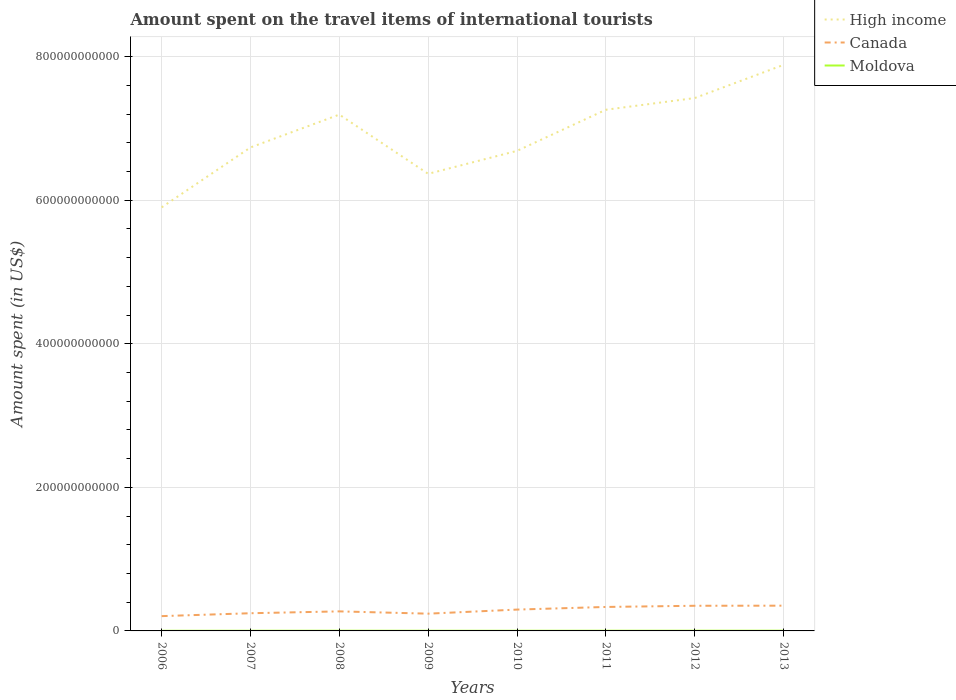Is the number of lines equal to the number of legend labels?
Keep it short and to the point. Yes. Across all years, what is the maximum amount spent on the travel items of international tourists in Canada?
Your response must be concise. 2.06e+1. In which year was the amount spent on the travel items of international tourists in High income maximum?
Offer a terse response. 2006. What is the total amount spent on the travel items of international tourists in Moldova in the graph?
Ensure brevity in your answer.  -2.00e+07. What is the difference between the highest and the second highest amount spent on the travel items of international tourists in Canada?
Provide a short and direct response. 1.46e+1. What is the difference between the highest and the lowest amount spent on the travel items of international tourists in Canada?
Offer a very short reply. 4. Is the amount spent on the travel items of international tourists in High income strictly greater than the amount spent on the travel items of international tourists in Canada over the years?
Give a very brief answer. No. How many lines are there?
Offer a very short reply. 3. What is the difference between two consecutive major ticks on the Y-axis?
Make the answer very short. 2.00e+11. Are the values on the major ticks of Y-axis written in scientific E-notation?
Keep it short and to the point. No. What is the title of the graph?
Your answer should be very brief. Amount spent on the travel items of international tourists. What is the label or title of the X-axis?
Keep it short and to the point. Years. What is the label or title of the Y-axis?
Your answer should be compact. Amount spent (in US$). What is the Amount spent (in US$) of High income in 2006?
Offer a very short reply. 5.90e+11. What is the Amount spent (in US$) in Canada in 2006?
Ensure brevity in your answer.  2.06e+1. What is the Amount spent (in US$) in Moldova in 2006?
Provide a short and direct response. 1.90e+08. What is the Amount spent (in US$) of High income in 2007?
Ensure brevity in your answer.  6.73e+11. What is the Amount spent (in US$) in Canada in 2007?
Provide a short and direct response. 2.46e+1. What is the Amount spent (in US$) in Moldova in 2007?
Your answer should be very brief. 2.33e+08. What is the Amount spent (in US$) in High income in 2008?
Provide a short and direct response. 7.19e+11. What is the Amount spent (in US$) in Canada in 2008?
Your response must be concise. 2.72e+1. What is the Amount spent (in US$) in Moldova in 2008?
Provide a short and direct response. 2.88e+08. What is the Amount spent (in US$) of High income in 2009?
Ensure brevity in your answer.  6.37e+11. What is the Amount spent (in US$) of Canada in 2009?
Ensure brevity in your answer.  2.40e+1. What is the Amount spent (in US$) in Moldova in 2009?
Offer a very short reply. 2.43e+08. What is the Amount spent (in US$) of High income in 2010?
Provide a short and direct response. 6.69e+11. What is the Amount spent (in US$) in Canada in 2010?
Provide a succinct answer. 2.97e+1. What is the Amount spent (in US$) in Moldova in 2010?
Offer a very short reply. 2.41e+08. What is the Amount spent (in US$) in High income in 2011?
Keep it short and to the point. 7.26e+11. What is the Amount spent (in US$) in Canada in 2011?
Provide a succinct answer. 3.34e+1. What is the Amount spent (in US$) of Moldova in 2011?
Your response must be concise. 2.77e+08. What is the Amount spent (in US$) in High income in 2012?
Your answer should be compact. 7.42e+11. What is the Amount spent (in US$) of Canada in 2012?
Keep it short and to the point. 3.50e+1. What is the Amount spent (in US$) in Moldova in 2012?
Your response must be concise. 3.08e+08. What is the Amount spent (in US$) in High income in 2013?
Offer a very short reply. 7.88e+11. What is the Amount spent (in US$) of Canada in 2013?
Your response must be concise. 3.52e+1. What is the Amount spent (in US$) in Moldova in 2013?
Your answer should be compact. 3.34e+08. Across all years, what is the maximum Amount spent (in US$) of High income?
Your answer should be compact. 7.88e+11. Across all years, what is the maximum Amount spent (in US$) in Canada?
Provide a succinct answer. 3.52e+1. Across all years, what is the maximum Amount spent (in US$) in Moldova?
Your answer should be compact. 3.34e+08. Across all years, what is the minimum Amount spent (in US$) of High income?
Give a very brief answer. 5.90e+11. Across all years, what is the minimum Amount spent (in US$) in Canada?
Your answer should be compact. 2.06e+1. Across all years, what is the minimum Amount spent (in US$) of Moldova?
Provide a short and direct response. 1.90e+08. What is the total Amount spent (in US$) of High income in the graph?
Give a very brief answer. 5.54e+12. What is the total Amount spent (in US$) in Canada in the graph?
Offer a terse response. 2.30e+11. What is the total Amount spent (in US$) of Moldova in the graph?
Make the answer very short. 2.11e+09. What is the difference between the Amount spent (in US$) in High income in 2006 and that in 2007?
Make the answer very short. -8.35e+1. What is the difference between the Amount spent (in US$) in Canada in 2006 and that in 2007?
Give a very brief answer. -4.03e+09. What is the difference between the Amount spent (in US$) of Moldova in 2006 and that in 2007?
Your response must be concise. -4.30e+07. What is the difference between the Amount spent (in US$) of High income in 2006 and that in 2008?
Provide a succinct answer. -1.29e+11. What is the difference between the Amount spent (in US$) in Canada in 2006 and that in 2008?
Your answer should be very brief. -6.61e+09. What is the difference between the Amount spent (in US$) of Moldova in 2006 and that in 2008?
Your response must be concise. -9.80e+07. What is the difference between the Amount spent (in US$) in High income in 2006 and that in 2009?
Give a very brief answer. -4.67e+1. What is the difference between the Amount spent (in US$) in Canada in 2006 and that in 2009?
Ensure brevity in your answer.  -3.42e+09. What is the difference between the Amount spent (in US$) in Moldova in 2006 and that in 2009?
Ensure brevity in your answer.  -5.30e+07. What is the difference between the Amount spent (in US$) of High income in 2006 and that in 2010?
Make the answer very short. -7.87e+1. What is the difference between the Amount spent (in US$) of Canada in 2006 and that in 2010?
Provide a short and direct response. -9.11e+09. What is the difference between the Amount spent (in US$) of Moldova in 2006 and that in 2010?
Offer a very short reply. -5.10e+07. What is the difference between the Amount spent (in US$) of High income in 2006 and that in 2011?
Your answer should be very brief. -1.36e+11. What is the difference between the Amount spent (in US$) in Canada in 2006 and that in 2011?
Your response must be concise. -1.28e+1. What is the difference between the Amount spent (in US$) in Moldova in 2006 and that in 2011?
Offer a terse response. -8.70e+07. What is the difference between the Amount spent (in US$) of High income in 2006 and that in 2012?
Offer a terse response. -1.52e+11. What is the difference between the Amount spent (in US$) in Canada in 2006 and that in 2012?
Keep it short and to the point. -1.44e+1. What is the difference between the Amount spent (in US$) of Moldova in 2006 and that in 2012?
Give a very brief answer. -1.18e+08. What is the difference between the Amount spent (in US$) in High income in 2006 and that in 2013?
Ensure brevity in your answer.  -1.98e+11. What is the difference between the Amount spent (in US$) of Canada in 2006 and that in 2013?
Provide a short and direct response. -1.46e+1. What is the difference between the Amount spent (in US$) of Moldova in 2006 and that in 2013?
Keep it short and to the point. -1.44e+08. What is the difference between the Amount spent (in US$) in High income in 2007 and that in 2008?
Provide a succinct answer. -4.58e+1. What is the difference between the Amount spent (in US$) in Canada in 2007 and that in 2008?
Offer a terse response. -2.58e+09. What is the difference between the Amount spent (in US$) of Moldova in 2007 and that in 2008?
Provide a succinct answer. -5.50e+07. What is the difference between the Amount spent (in US$) of High income in 2007 and that in 2009?
Your response must be concise. 3.67e+1. What is the difference between the Amount spent (in US$) in Canada in 2007 and that in 2009?
Provide a short and direct response. 6.03e+08. What is the difference between the Amount spent (in US$) of Moldova in 2007 and that in 2009?
Keep it short and to the point. -1.00e+07. What is the difference between the Amount spent (in US$) of High income in 2007 and that in 2010?
Your answer should be very brief. 4.75e+09. What is the difference between the Amount spent (in US$) of Canada in 2007 and that in 2010?
Your answer should be very brief. -5.09e+09. What is the difference between the Amount spent (in US$) of Moldova in 2007 and that in 2010?
Offer a terse response. -8.00e+06. What is the difference between the Amount spent (in US$) in High income in 2007 and that in 2011?
Provide a succinct answer. -5.25e+1. What is the difference between the Amount spent (in US$) in Canada in 2007 and that in 2011?
Provide a succinct answer. -8.75e+09. What is the difference between the Amount spent (in US$) in Moldova in 2007 and that in 2011?
Provide a succinct answer. -4.40e+07. What is the difference between the Amount spent (in US$) of High income in 2007 and that in 2012?
Make the answer very short. -6.88e+1. What is the difference between the Amount spent (in US$) in Canada in 2007 and that in 2012?
Offer a very short reply. -1.04e+1. What is the difference between the Amount spent (in US$) in Moldova in 2007 and that in 2012?
Your answer should be very brief. -7.50e+07. What is the difference between the Amount spent (in US$) of High income in 2007 and that in 2013?
Offer a very short reply. -1.15e+11. What is the difference between the Amount spent (in US$) in Canada in 2007 and that in 2013?
Provide a short and direct response. -1.05e+1. What is the difference between the Amount spent (in US$) in Moldova in 2007 and that in 2013?
Your answer should be compact. -1.01e+08. What is the difference between the Amount spent (in US$) in High income in 2008 and that in 2009?
Provide a succinct answer. 8.25e+1. What is the difference between the Amount spent (in US$) in Canada in 2008 and that in 2009?
Provide a succinct answer. 3.19e+09. What is the difference between the Amount spent (in US$) in Moldova in 2008 and that in 2009?
Provide a succinct answer. 4.50e+07. What is the difference between the Amount spent (in US$) of High income in 2008 and that in 2010?
Offer a very short reply. 5.05e+1. What is the difference between the Amount spent (in US$) of Canada in 2008 and that in 2010?
Make the answer very short. -2.50e+09. What is the difference between the Amount spent (in US$) of Moldova in 2008 and that in 2010?
Give a very brief answer. 4.70e+07. What is the difference between the Amount spent (in US$) in High income in 2008 and that in 2011?
Offer a terse response. -6.76e+09. What is the difference between the Amount spent (in US$) of Canada in 2008 and that in 2011?
Your answer should be compact. -6.16e+09. What is the difference between the Amount spent (in US$) in Moldova in 2008 and that in 2011?
Provide a short and direct response. 1.10e+07. What is the difference between the Amount spent (in US$) in High income in 2008 and that in 2012?
Ensure brevity in your answer.  -2.31e+1. What is the difference between the Amount spent (in US$) of Canada in 2008 and that in 2012?
Your answer should be very brief. -7.81e+09. What is the difference between the Amount spent (in US$) in Moldova in 2008 and that in 2012?
Your answer should be compact. -2.00e+07. What is the difference between the Amount spent (in US$) in High income in 2008 and that in 2013?
Your response must be concise. -6.93e+1. What is the difference between the Amount spent (in US$) of Canada in 2008 and that in 2013?
Ensure brevity in your answer.  -7.94e+09. What is the difference between the Amount spent (in US$) in Moldova in 2008 and that in 2013?
Provide a short and direct response. -4.60e+07. What is the difference between the Amount spent (in US$) in High income in 2009 and that in 2010?
Your answer should be very brief. -3.20e+1. What is the difference between the Amount spent (in US$) of Canada in 2009 and that in 2010?
Keep it short and to the point. -5.69e+09. What is the difference between the Amount spent (in US$) in High income in 2009 and that in 2011?
Offer a terse response. -8.93e+1. What is the difference between the Amount spent (in US$) in Canada in 2009 and that in 2011?
Your answer should be compact. -9.35e+09. What is the difference between the Amount spent (in US$) in Moldova in 2009 and that in 2011?
Provide a succinct answer. -3.40e+07. What is the difference between the Amount spent (in US$) in High income in 2009 and that in 2012?
Keep it short and to the point. -1.06e+11. What is the difference between the Amount spent (in US$) in Canada in 2009 and that in 2012?
Provide a succinct answer. -1.10e+1. What is the difference between the Amount spent (in US$) in Moldova in 2009 and that in 2012?
Keep it short and to the point. -6.50e+07. What is the difference between the Amount spent (in US$) in High income in 2009 and that in 2013?
Your answer should be compact. -1.52e+11. What is the difference between the Amount spent (in US$) of Canada in 2009 and that in 2013?
Provide a succinct answer. -1.11e+1. What is the difference between the Amount spent (in US$) of Moldova in 2009 and that in 2013?
Provide a succinct answer. -9.10e+07. What is the difference between the Amount spent (in US$) in High income in 2010 and that in 2011?
Provide a succinct answer. -5.73e+1. What is the difference between the Amount spent (in US$) in Canada in 2010 and that in 2011?
Offer a very short reply. -3.66e+09. What is the difference between the Amount spent (in US$) in Moldova in 2010 and that in 2011?
Offer a terse response. -3.60e+07. What is the difference between the Amount spent (in US$) in High income in 2010 and that in 2012?
Your answer should be compact. -7.36e+1. What is the difference between the Amount spent (in US$) in Canada in 2010 and that in 2012?
Your answer should be very brief. -5.31e+09. What is the difference between the Amount spent (in US$) of Moldova in 2010 and that in 2012?
Make the answer very short. -6.70e+07. What is the difference between the Amount spent (in US$) in High income in 2010 and that in 2013?
Offer a very short reply. -1.20e+11. What is the difference between the Amount spent (in US$) in Canada in 2010 and that in 2013?
Offer a very short reply. -5.44e+09. What is the difference between the Amount spent (in US$) in Moldova in 2010 and that in 2013?
Provide a short and direct response. -9.30e+07. What is the difference between the Amount spent (in US$) in High income in 2011 and that in 2012?
Make the answer very short. -1.63e+1. What is the difference between the Amount spent (in US$) in Canada in 2011 and that in 2012?
Ensure brevity in your answer.  -1.65e+09. What is the difference between the Amount spent (in US$) in Moldova in 2011 and that in 2012?
Make the answer very short. -3.10e+07. What is the difference between the Amount spent (in US$) in High income in 2011 and that in 2013?
Offer a terse response. -6.25e+1. What is the difference between the Amount spent (in US$) in Canada in 2011 and that in 2013?
Your response must be concise. -1.78e+09. What is the difference between the Amount spent (in US$) in Moldova in 2011 and that in 2013?
Make the answer very short. -5.70e+07. What is the difference between the Amount spent (in US$) in High income in 2012 and that in 2013?
Make the answer very short. -4.62e+1. What is the difference between the Amount spent (in US$) in Canada in 2012 and that in 2013?
Offer a terse response. -1.32e+08. What is the difference between the Amount spent (in US$) of Moldova in 2012 and that in 2013?
Provide a short and direct response. -2.60e+07. What is the difference between the Amount spent (in US$) in High income in 2006 and the Amount spent (in US$) in Canada in 2007?
Ensure brevity in your answer.  5.65e+11. What is the difference between the Amount spent (in US$) of High income in 2006 and the Amount spent (in US$) of Moldova in 2007?
Offer a very short reply. 5.90e+11. What is the difference between the Amount spent (in US$) in Canada in 2006 and the Amount spent (in US$) in Moldova in 2007?
Your answer should be very brief. 2.04e+1. What is the difference between the Amount spent (in US$) of High income in 2006 and the Amount spent (in US$) of Canada in 2008?
Offer a terse response. 5.63e+11. What is the difference between the Amount spent (in US$) in High income in 2006 and the Amount spent (in US$) in Moldova in 2008?
Provide a succinct answer. 5.90e+11. What is the difference between the Amount spent (in US$) in Canada in 2006 and the Amount spent (in US$) in Moldova in 2008?
Offer a very short reply. 2.03e+1. What is the difference between the Amount spent (in US$) of High income in 2006 and the Amount spent (in US$) of Canada in 2009?
Your answer should be compact. 5.66e+11. What is the difference between the Amount spent (in US$) of High income in 2006 and the Amount spent (in US$) of Moldova in 2009?
Offer a terse response. 5.90e+11. What is the difference between the Amount spent (in US$) in Canada in 2006 and the Amount spent (in US$) in Moldova in 2009?
Provide a succinct answer. 2.04e+1. What is the difference between the Amount spent (in US$) in High income in 2006 and the Amount spent (in US$) in Canada in 2010?
Provide a short and direct response. 5.60e+11. What is the difference between the Amount spent (in US$) of High income in 2006 and the Amount spent (in US$) of Moldova in 2010?
Give a very brief answer. 5.90e+11. What is the difference between the Amount spent (in US$) of Canada in 2006 and the Amount spent (in US$) of Moldova in 2010?
Provide a short and direct response. 2.04e+1. What is the difference between the Amount spent (in US$) of High income in 2006 and the Amount spent (in US$) of Canada in 2011?
Provide a succinct answer. 5.57e+11. What is the difference between the Amount spent (in US$) of High income in 2006 and the Amount spent (in US$) of Moldova in 2011?
Offer a very short reply. 5.90e+11. What is the difference between the Amount spent (in US$) in Canada in 2006 and the Amount spent (in US$) in Moldova in 2011?
Provide a short and direct response. 2.03e+1. What is the difference between the Amount spent (in US$) of High income in 2006 and the Amount spent (in US$) of Canada in 2012?
Keep it short and to the point. 5.55e+11. What is the difference between the Amount spent (in US$) of High income in 2006 and the Amount spent (in US$) of Moldova in 2012?
Your answer should be very brief. 5.90e+11. What is the difference between the Amount spent (in US$) of Canada in 2006 and the Amount spent (in US$) of Moldova in 2012?
Your response must be concise. 2.03e+1. What is the difference between the Amount spent (in US$) of High income in 2006 and the Amount spent (in US$) of Canada in 2013?
Provide a short and direct response. 5.55e+11. What is the difference between the Amount spent (in US$) of High income in 2006 and the Amount spent (in US$) of Moldova in 2013?
Your response must be concise. 5.90e+11. What is the difference between the Amount spent (in US$) of Canada in 2006 and the Amount spent (in US$) of Moldova in 2013?
Keep it short and to the point. 2.03e+1. What is the difference between the Amount spent (in US$) of High income in 2007 and the Amount spent (in US$) of Canada in 2008?
Your response must be concise. 6.46e+11. What is the difference between the Amount spent (in US$) of High income in 2007 and the Amount spent (in US$) of Moldova in 2008?
Make the answer very short. 6.73e+11. What is the difference between the Amount spent (in US$) of Canada in 2007 and the Amount spent (in US$) of Moldova in 2008?
Make the answer very short. 2.44e+1. What is the difference between the Amount spent (in US$) in High income in 2007 and the Amount spent (in US$) in Canada in 2009?
Keep it short and to the point. 6.49e+11. What is the difference between the Amount spent (in US$) of High income in 2007 and the Amount spent (in US$) of Moldova in 2009?
Your response must be concise. 6.73e+11. What is the difference between the Amount spent (in US$) in Canada in 2007 and the Amount spent (in US$) in Moldova in 2009?
Offer a terse response. 2.44e+1. What is the difference between the Amount spent (in US$) of High income in 2007 and the Amount spent (in US$) of Canada in 2010?
Provide a succinct answer. 6.44e+11. What is the difference between the Amount spent (in US$) in High income in 2007 and the Amount spent (in US$) in Moldova in 2010?
Ensure brevity in your answer.  6.73e+11. What is the difference between the Amount spent (in US$) of Canada in 2007 and the Amount spent (in US$) of Moldova in 2010?
Provide a short and direct response. 2.44e+1. What is the difference between the Amount spent (in US$) of High income in 2007 and the Amount spent (in US$) of Canada in 2011?
Provide a succinct answer. 6.40e+11. What is the difference between the Amount spent (in US$) of High income in 2007 and the Amount spent (in US$) of Moldova in 2011?
Give a very brief answer. 6.73e+11. What is the difference between the Amount spent (in US$) in Canada in 2007 and the Amount spent (in US$) in Moldova in 2011?
Your answer should be very brief. 2.44e+1. What is the difference between the Amount spent (in US$) in High income in 2007 and the Amount spent (in US$) in Canada in 2012?
Provide a succinct answer. 6.38e+11. What is the difference between the Amount spent (in US$) of High income in 2007 and the Amount spent (in US$) of Moldova in 2012?
Keep it short and to the point. 6.73e+11. What is the difference between the Amount spent (in US$) in Canada in 2007 and the Amount spent (in US$) in Moldova in 2012?
Provide a succinct answer. 2.43e+1. What is the difference between the Amount spent (in US$) in High income in 2007 and the Amount spent (in US$) in Canada in 2013?
Provide a succinct answer. 6.38e+11. What is the difference between the Amount spent (in US$) in High income in 2007 and the Amount spent (in US$) in Moldova in 2013?
Keep it short and to the point. 6.73e+11. What is the difference between the Amount spent (in US$) in Canada in 2007 and the Amount spent (in US$) in Moldova in 2013?
Offer a very short reply. 2.43e+1. What is the difference between the Amount spent (in US$) in High income in 2008 and the Amount spent (in US$) in Canada in 2009?
Ensure brevity in your answer.  6.95e+11. What is the difference between the Amount spent (in US$) in High income in 2008 and the Amount spent (in US$) in Moldova in 2009?
Ensure brevity in your answer.  7.19e+11. What is the difference between the Amount spent (in US$) of Canada in 2008 and the Amount spent (in US$) of Moldova in 2009?
Make the answer very short. 2.70e+1. What is the difference between the Amount spent (in US$) of High income in 2008 and the Amount spent (in US$) of Canada in 2010?
Provide a succinct answer. 6.89e+11. What is the difference between the Amount spent (in US$) in High income in 2008 and the Amount spent (in US$) in Moldova in 2010?
Offer a very short reply. 7.19e+11. What is the difference between the Amount spent (in US$) in Canada in 2008 and the Amount spent (in US$) in Moldova in 2010?
Provide a short and direct response. 2.70e+1. What is the difference between the Amount spent (in US$) of High income in 2008 and the Amount spent (in US$) of Canada in 2011?
Offer a terse response. 6.86e+11. What is the difference between the Amount spent (in US$) in High income in 2008 and the Amount spent (in US$) in Moldova in 2011?
Make the answer very short. 7.19e+11. What is the difference between the Amount spent (in US$) of Canada in 2008 and the Amount spent (in US$) of Moldova in 2011?
Provide a succinct answer. 2.69e+1. What is the difference between the Amount spent (in US$) in High income in 2008 and the Amount spent (in US$) in Canada in 2012?
Provide a succinct answer. 6.84e+11. What is the difference between the Amount spent (in US$) of High income in 2008 and the Amount spent (in US$) of Moldova in 2012?
Make the answer very short. 7.19e+11. What is the difference between the Amount spent (in US$) in Canada in 2008 and the Amount spent (in US$) in Moldova in 2012?
Give a very brief answer. 2.69e+1. What is the difference between the Amount spent (in US$) of High income in 2008 and the Amount spent (in US$) of Canada in 2013?
Offer a terse response. 6.84e+11. What is the difference between the Amount spent (in US$) in High income in 2008 and the Amount spent (in US$) in Moldova in 2013?
Give a very brief answer. 7.19e+11. What is the difference between the Amount spent (in US$) of Canada in 2008 and the Amount spent (in US$) of Moldova in 2013?
Offer a terse response. 2.69e+1. What is the difference between the Amount spent (in US$) in High income in 2009 and the Amount spent (in US$) in Canada in 2010?
Offer a very short reply. 6.07e+11. What is the difference between the Amount spent (in US$) in High income in 2009 and the Amount spent (in US$) in Moldova in 2010?
Offer a terse response. 6.36e+11. What is the difference between the Amount spent (in US$) of Canada in 2009 and the Amount spent (in US$) of Moldova in 2010?
Your answer should be compact. 2.38e+1. What is the difference between the Amount spent (in US$) of High income in 2009 and the Amount spent (in US$) of Canada in 2011?
Your answer should be very brief. 6.03e+11. What is the difference between the Amount spent (in US$) in High income in 2009 and the Amount spent (in US$) in Moldova in 2011?
Provide a succinct answer. 6.36e+11. What is the difference between the Amount spent (in US$) in Canada in 2009 and the Amount spent (in US$) in Moldova in 2011?
Give a very brief answer. 2.38e+1. What is the difference between the Amount spent (in US$) of High income in 2009 and the Amount spent (in US$) of Canada in 2012?
Ensure brevity in your answer.  6.02e+11. What is the difference between the Amount spent (in US$) of High income in 2009 and the Amount spent (in US$) of Moldova in 2012?
Make the answer very short. 6.36e+11. What is the difference between the Amount spent (in US$) in Canada in 2009 and the Amount spent (in US$) in Moldova in 2012?
Keep it short and to the point. 2.37e+1. What is the difference between the Amount spent (in US$) in High income in 2009 and the Amount spent (in US$) in Canada in 2013?
Provide a succinct answer. 6.02e+11. What is the difference between the Amount spent (in US$) of High income in 2009 and the Amount spent (in US$) of Moldova in 2013?
Offer a very short reply. 6.36e+11. What is the difference between the Amount spent (in US$) of Canada in 2009 and the Amount spent (in US$) of Moldova in 2013?
Your response must be concise. 2.37e+1. What is the difference between the Amount spent (in US$) of High income in 2010 and the Amount spent (in US$) of Canada in 2011?
Provide a succinct answer. 6.35e+11. What is the difference between the Amount spent (in US$) of High income in 2010 and the Amount spent (in US$) of Moldova in 2011?
Give a very brief answer. 6.68e+11. What is the difference between the Amount spent (in US$) in Canada in 2010 and the Amount spent (in US$) in Moldova in 2011?
Provide a succinct answer. 2.94e+1. What is the difference between the Amount spent (in US$) in High income in 2010 and the Amount spent (in US$) in Canada in 2012?
Offer a very short reply. 6.34e+11. What is the difference between the Amount spent (in US$) in High income in 2010 and the Amount spent (in US$) in Moldova in 2012?
Your answer should be very brief. 6.68e+11. What is the difference between the Amount spent (in US$) in Canada in 2010 and the Amount spent (in US$) in Moldova in 2012?
Ensure brevity in your answer.  2.94e+1. What is the difference between the Amount spent (in US$) in High income in 2010 and the Amount spent (in US$) in Canada in 2013?
Your answer should be very brief. 6.34e+11. What is the difference between the Amount spent (in US$) of High income in 2010 and the Amount spent (in US$) of Moldova in 2013?
Make the answer very short. 6.68e+11. What is the difference between the Amount spent (in US$) of Canada in 2010 and the Amount spent (in US$) of Moldova in 2013?
Make the answer very short. 2.94e+1. What is the difference between the Amount spent (in US$) of High income in 2011 and the Amount spent (in US$) of Canada in 2012?
Ensure brevity in your answer.  6.91e+11. What is the difference between the Amount spent (in US$) in High income in 2011 and the Amount spent (in US$) in Moldova in 2012?
Make the answer very short. 7.26e+11. What is the difference between the Amount spent (in US$) in Canada in 2011 and the Amount spent (in US$) in Moldova in 2012?
Your answer should be very brief. 3.31e+1. What is the difference between the Amount spent (in US$) in High income in 2011 and the Amount spent (in US$) in Canada in 2013?
Give a very brief answer. 6.91e+11. What is the difference between the Amount spent (in US$) of High income in 2011 and the Amount spent (in US$) of Moldova in 2013?
Offer a very short reply. 7.26e+11. What is the difference between the Amount spent (in US$) in Canada in 2011 and the Amount spent (in US$) in Moldova in 2013?
Keep it short and to the point. 3.31e+1. What is the difference between the Amount spent (in US$) of High income in 2012 and the Amount spent (in US$) of Canada in 2013?
Ensure brevity in your answer.  7.07e+11. What is the difference between the Amount spent (in US$) of High income in 2012 and the Amount spent (in US$) of Moldova in 2013?
Offer a terse response. 7.42e+11. What is the difference between the Amount spent (in US$) of Canada in 2012 and the Amount spent (in US$) of Moldova in 2013?
Your answer should be very brief. 3.47e+1. What is the average Amount spent (in US$) of High income per year?
Provide a short and direct response. 6.93e+11. What is the average Amount spent (in US$) of Canada per year?
Your answer should be very brief. 2.87e+1. What is the average Amount spent (in US$) in Moldova per year?
Provide a short and direct response. 2.64e+08. In the year 2006, what is the difference between the Amount spent (in US$) in High income and Amount spent (in US$) in Canada?
Provide a succinct answer. 5.69e+11. In the year 2006, what is the difference between the Amount spent (in US$) in High income and Amount spent (in US$) in Moldova?
Keep it short and to the point. 5.90e+11. In the year 2006, what is the difference between the Amount spent (in US$) in Canada and Amount spent (in US$) in Moldova?
Your answer should be compact. 2.04e+1. In the year 2007, what is the difference between the Amount spent (in US$) in High income and Amount spent (in US$) in Canada?
Ensure brevity in your answer.  6.49e+11. In the year 2007, what is the difference between the Amount spent (in US$) of High income and Amount spent (in US$) of Moldova?
Keep it short and to the point. 6.73e+11. In the year 2007, what is the difference between the Amount spent (in US$) in Canada and Amount spent (in US$) in Moldova?
Your response must be concise. 2.44e+1. In the year 2008, what is the difference between the Amount spent (in US$) in High income and Amount spent (in US$) in Canada?
Provide a short and direct response. 6.92e+11. In the year 2008, what is the difference between the Amount spent (in US$) in High income and Amount spent (in US$) in Moldova?
Your answer should be very brief. 7.19e+11. In the year 2008, what is the difference between the Amount spent (in US$) in Canada and Amount spent (in US$) in Moldova?
Keep it short and to the point. 2.69e+1. In the year 2009, what is the difference between the Amount spent (in US$) of High income and Amount spent (in US$) of Canada?
Your answer should be very brief. 6.13e+11. In the year 2009, what is the difference between the Amount spent (in US$) in High income and Amount spent (in US$) in Moldova?
Ensure brevity in your answer.  6.36e+11. In the year 2009, what is the difference between the Amount spent (in US$) of Canada and Amount spent (in US$) of Moldova?
Keep it short and to the point. 2.38e+1. In the year 2010, what is the difference between the Amount spent (in US$) in High income and Amount spent (in US$) in Canada?
Provide a short and direct response. 6.39e+11. In the year 2010, what is the difference between the Amount spent (in US$) of High income and Amount spent (in US$) of Moldova?
Provide a short and direct response. 6.68e+11. In the year 2010, what is the difference between the Amount spent (in US$) in Canada and Amount spent (in US$) in Moldova?
Offer a very short reply. 2.95e+1. In the year 2011, what is the difference between the Amount spent (in US$) in High income and Amount spent (in US$) in Canada?
Make the answer very short. 6.93e+11. In the year 2011, what is the difference between the Amount spent (in US$) of High income and Amount spent (in US$) of Moldova?
Ensure brevity in your answer.  7.26e+11. In the year 2011, what is the difference between the Amount spent (in US$) in Canada and Amount spent (in US$) in Moldova?
Offer a very short reply. 3.31e+1. In the year 2012, what is the difference between the Amount spent (in US$) of High income and Amount spent (in US$) of Canada?
Keep it short and to the point. 7.07e+11. In the year 2012, what is the difference between the Amount spent (in US$) of High income and Amount spent (in US$) of Moldova?
Give a very brief answer. 7.42e+11. In the year 2012, what is the difference between the Amount spent (in US$) of Canada and Amount spent (in US$) of Moldova?
Provide a short and direct response. 3.47e+1. In the year 2013, what is the difference between the Amount spent (in US$) in High income and Amount spent (in US$) in Canada?
Make the answer very short. 7.53e+11. In the year 2013, what is the difference between the Amount spent (in US$) in High income and Amount spent (in US$) in Moldova?
Your response must be concise. 7.88e+11. In the year 2013, what is the difference between the Amount spent (in US$) in Canada and Amount spent (in US$) in Moldova?
Keep it short and to the point. 3.48e+1. What is the ratio of the Amount spent (in US$) of High income in 2006 to that in 2007?
Offer a very short reply. 0.88. What is the ratio of the Amount spent (in US$) of Canada in 2006 to that in 2007?
Your answer should be very brief. 0.84. What is the ratio of the Amount spent (in US$) in Moldova in 2006 to that in 2007?
Your answer should be compact. 0.82. What is the ratio of the Amount spent (in US$) in High income in 2006 to that in 2008?
Offer a terse response. 0.82. What is the ratio of the Amount spent (in US$) in Canada in 2006 to that in 2008?
Provide a succinct answer. 0.76. What is the ratio of the Amount spent (in US$) in Moldova in 2006 to that in 2008?
Your answer should be compact. 0.66. What is the ratio of the Amount spent (in US$) in High income in 2006 to that in 2009?
Your response must be concise. 0.93. What is the ratio of the Amount spent (in US$) of Canada in 2006 to that in 2009?
Ensure brevity in your answer.  0.86. What is the ratio of the Amount spent (in US$) of Moldova in 2006 to that in 2009?
Make the answer very short. 0.78. What is the ratio of the Amount spent (in US$) in High income in 2006 to that in 2010?
Offer a very short reply. 0.88. What is the ratio of the Amount spent (in US$) in Canada in 2006 to that in 2010?
Your response must be concise. 0.69. What is the ratio of the Amount spent (in US$) of Moldova in 2006 to that in 2010?
Provide a succinct answer. 0.79. What is the ratio of the Amount spent (in US$) of High income in 2006 to that in 2011?
Keep it short and to the point. 0.81. What is the ratio of the Amount spent (in US$) in Canada in 2006 to that in 2011?
Your answer should be compact. 0.62. What is the ratio of the Amount spent (in US$) of Moldova in 2006 to that in 2011?
Ensure brevity in your answer.  0.69. What is the ratio of the Amount spent (in US$) of High income in 2006 to that in 2012?
Your answer should be compact. 0.79. What is the ratio of the Amount spent (in US$) of Canada in 2006 to that in 2012?
Give a very brief answer. 0.59. What is the ratio of the Amount spent (in US$) in Moldova in 2006 to that in 2012?
Offer a terse response. 0.62. What is the ratio of the Amount spent (in US$) of High income in 2006 to that in 2013?
Your answer should be very brief. 0.75. What is the ratio of the Amount spent (in US$) in Canada in 2006 to that in 2013?
Give a very brief answer. 0.59. What is the ratio of the Amount spent (in US$) of Moldova in 2006 to that in 2013?
Your answer should be very brief. 0.57. What is the ratio of the Amount spent (in US$) of High income in 2007 to that in 2008?
Give a very brief answer. 0.94. What is the ratio of the Amount spent (in US$) in Canada in 2007 to that in 2008?
Your answer should be very brief. 0.91. What is the ratio of the Amount spent (in US$) of Moldova in 2007 to that in 2008?
Offer a very short reply. 0.81. What is the ratio of the Amount spent (in US$) in High income in 2007 to that in 2009?
Your response must be concise. 1.06. What is the ratio of the Amount spent (in US$) in Canada in 2007 to that in 2009?
Give a very brief answer. 1.03. What is the ratio of the Amount spent (in US$) in Moldova in 2007 to that in 2009?
Your answer should be very brief. 0.96. What is the ratio of the Amount spent (in US$) of High income in 2007 to that in 2010?
Your answer should be compact. 1.01. What is the ratio of the Amount spent (in US$) of Canada in 2007 to that in 2010?
Your response must be concise. 0.83. What is the ratio of the Amount spent (in US$) of Moldova in 2007 to that in 2010?
Keep it short and to the point. 0.97. What is the ratio of the Amount spent (in US$) of High income in 2007 to that in 2011?
Offer a very short reply. 0.93. What is the ratio of the Amount spent (in US$) in Canada in 2007 to that in 2011?
Provide a succinct answer. 0.74. What is the ratio of the Amount spent (in US$) of Moldova in 2007 to that in 2011?
Offer a very short reply. 0.84. What is the ratio of the Amount spent (in US$) in High income in 2007 to that in 2012?
Make the answer very short. 0.91. What is the ratio of the Amount spent (in US$) in Canada in 2007 to that in 2012?
Keep it short and to the point. 0.7. What is the ratio of the Amount spent (in US$) of Moldova in 2007 to that in 2012?
Ensure brevity in your answer.  0.76. What is the ratio of the Amount spent (in US$) in High income in 2007 to that in 2013?
Ensure brevity in your answer.  0.85. What is the ratio of the Amount spent (in US$) of Canada in 2007 to that in 2013?
Offer a terse response. 0.7. What is the ratio of the Amount spent (in US$) of Moldova in 2007 to that in 2013?
Offer a very short reply. 0.7. What is the ratio of the Amount spent (in US$) in High income in 2008 to that in 2009?
Your response must be concise. 1.13. What is the ratio of the Amount spent (in US$) of Canada in 2008 to that in 2009?
Offer a very short reply. 1.13. What is the ratio of the Amount spent (in US$) of Moldova in 2008 to that in 2009?
Ensure brevity in your answer.  1.19. What is the ratio of the Amount spent (in US$) of High income in 2008 to that in 2010?
Keep it short and to the point. 1.08. What is the ratio of the Amount spent (in US$) in Canada in 2008 to that in 2010?
Give a very brief answer. 0.92. What is the ratio of the Amount spent (in US$) in Moldova in 2008 to that in 2010?
Your answer should be very brief. 1.2. What is the ratio of the Amount spent (in US$) of High income in 2008 to that in 2011?
Make the answer very short. 0.99. What is the ratio of the Amount spent (in US$) of Canada in 2008 to that in 2011?
Make the answer very short. 0.82. What is the ratio of the Amount spent (in US$) in Moldova in 2008 to that in 2011?
Offer a terse response. 1.04. What is the ratio of the Amount spent (in US$) of High income in 2008 to that in 2012?
Provide a succinct answer. 0.97. What is the ratio of the Amount spent (in US$) of Canada in 2008 to that in 2012?
Make the answer very short. 0.78. What is the ratio of the Amount spent (in US$) in Moldova in 2008 to that in 2012?
Offer a terse response. 0.94. What is the ratio of the Amount spent (in US$) in High income in 2008 to that in 2013?
Offer a very short reply. 0.91. What is the ratio of the Amount spent (in US$) in Canada in 2008 to that in 2013?
Keep it short and to the point. 0.77. What is the ratio of the Amount spent (in US$) of Moldova in 2008 to that in 2013?
Provide a succinct answer. 0.86. What is the ratio of the Amount spent (in US$) in High income in 2009 to that in 2010?
Provide a short and direct response. 0.95. What is the ratio of the Amount spent (in US$) in Canada in 2009 to that in 2010?
Provide a succinct answer. 0.81. What is the ratio of the Amount spent (in US$) in Moldova in 2009 to that in 2010?
Keep it short and to the point. 1.01. What is the ratio of the Amount spent (in US$) in High income in 2009 to that in 2011?
Your response must be concise. 0.88. What is the ratio of the Amount spent (in US$) of Canada in 2009 to that in 2011?
Provide a short and direct response. 0.72. What is the ratio of the Amount spent (in US$) of Moldova in 2009 to that in 2011?
Your response must be concise. 0.88. What is the ratio of the Amount spent (in US$) of High income in 2009 to that in 2012?
Offer a terse response. 0.86. What is the ratio of the Amount spent (in US$) of Canada in 2009 to that in 2012?
Offer a terse response. 0.69. What is the ratio of the Amount spent (in US$) of Moldova in 2009 to that in 2012?
Offer a terse response. 0.79. What is the ratio of the Amount spent (in US$) of High income in 2009 to that in 2013?
Offer a very short reply. 0.81. What is the ratio of the Amount spent (in US$) of Canada in 2009 to that in 2013?
Make the answer very short. 0.68. What is the ratio of the Amount spent (in US$) of Moldova in 2009 to that in 2013?
Make the answer very short. 0.73. What is the ratio of the Amount spent (in US$) in High income in 2010 to that in 2011?
Offer a terse response. 0.92. What is the ratio of the Amount spent (in US$) in Canada in 2010 to that in 2011?
Keep it short and to the point. 0.89. What is the ratio of the Amount spent (in US$) of Moldova in 2010 to that in 2011?
Offer a terse response. 0.87. What is the ratio of the Amount spent (in US$) of High income in 2010 to that in 2012?
Offer a terse response. 0.9. What is the ratio of the Amount spent (in US$) of Canada in 2010 to that in 2012?
Ensure brevity in your answer.  0.85. What is the ratio of the Amount spent (in US$) in Moldova in 2010 to that in 2012?
Provide a succinct answer. 0.78. What is the ratio of the Amount spent (in US$) of High income in 2010 to that in 2013?
Provide a succinct answer. 0.85. What is the ratio of the Amount spent (in US$) in Canada in 2010 to that in 2013?
Provide a short and direct response. 0.85. What is the ratio of the Amount spent (in US$) of Moldova in 2010 to that in 2013?
Provide a succinct answer. 0.72. What is the ratio of the Amount spent (in US$) in High income in 2011 to that in 2012?
Your answer should be compact. 0.98. What is the ratio of the Amount spent (in US$) of Canada in 2011 to that in 2012?
Offer a very short reply. 0.95. What is the ratio of the Amount spent (in US$) in Moldova in 2011 to that in 2012?
Provide a short and direct response. 0.9. What is the ratio of the Amount spent (in US$) of High income in 2011 to that in 2013?
Your response must be concise. 0.92. What is the ratio of the Amount spent (in US$) of Canada in 2011 to that in 2013?
Give a very brief answer. 0.95. What is the ratio of the Amount spent (in US$) of Moldova in 2011 to that in 2013?
Keep it short and to the point. 0.83. What is the ratio of the Amount spent (in US$) in High income in 2012 to that in 2013?
Provide a succinct answer. 0.94. What is the ratio of the Amount spent (in US$) in Moldova in 2012 to that in 2013?
Make the answer very short. 0.92. What is the difference between the highest and the second highest Amount spent (in US$) of High income?
Keep it short and to the point. 4.62e+1. What is the difference between the highest and the second highest Amount spent (in US$) in Canada?
Provide a succinct answer. 1.32e+08. What is the difference between the highest and the second highest Amount spent (in US$) in Moldova?
Your answer should be very brief. 2.60e+07. What is the difference between the highest and the lowest Amount spent (in US$) of High income?
Ensure brevity in your answer.  1.98e+11. What is the difference between the highest and the lowest Amount spent (in US$) in Canada?
Offer a terse response. 1.46e+1. What is the difference between the highest and the lowest Amount spent (in US$) of Moldova?
Offer a terse response. 1.44e+08. 